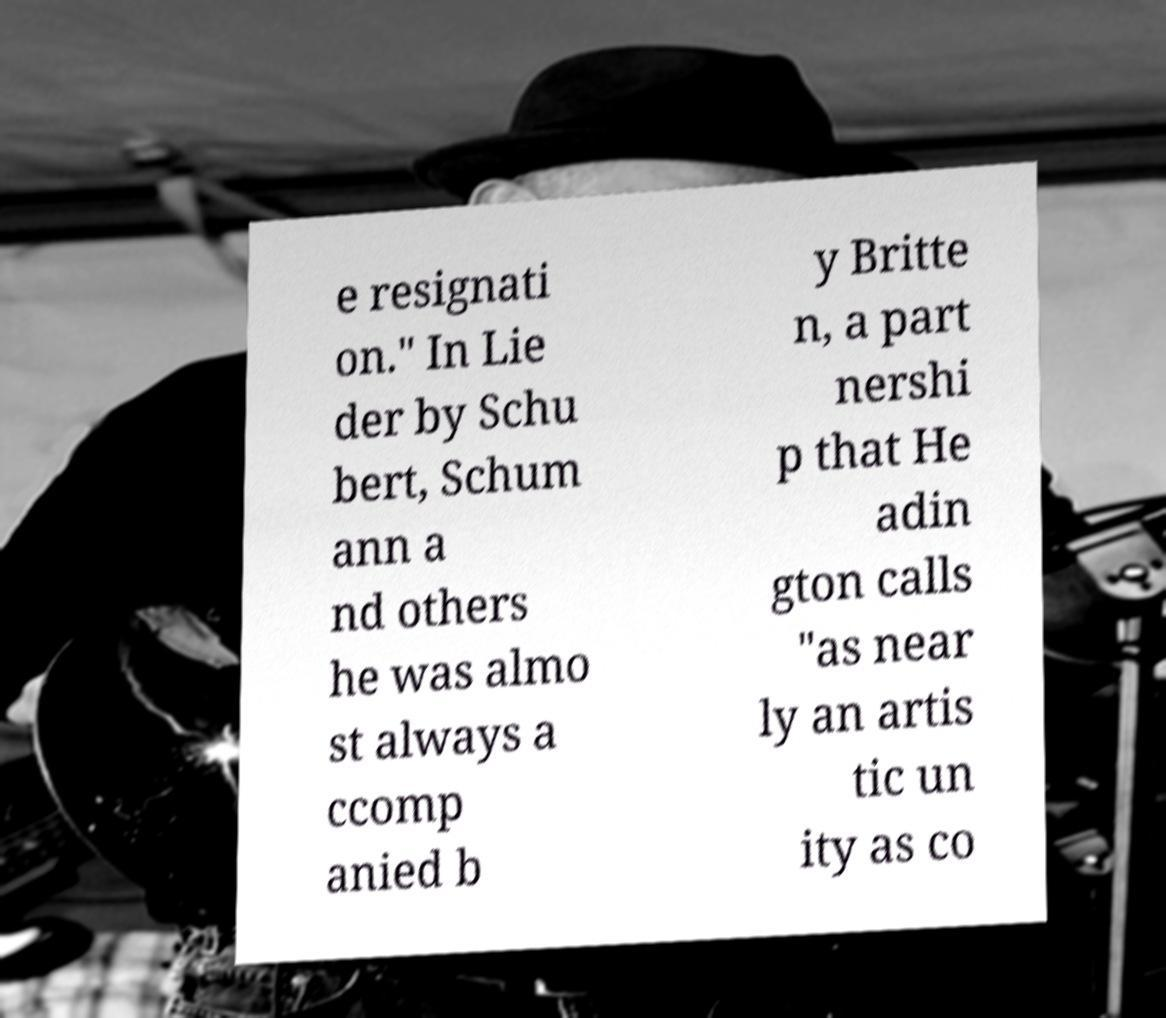Can you accurately transcribe the text from the provided image for me? e resignati on." In Lie der by Schu bert, Schum ann a nd others he was almo st always a ccomp anied b y Britte n, a part nershi p that He adin gton calls "as near ly an artis tic un ity as co 